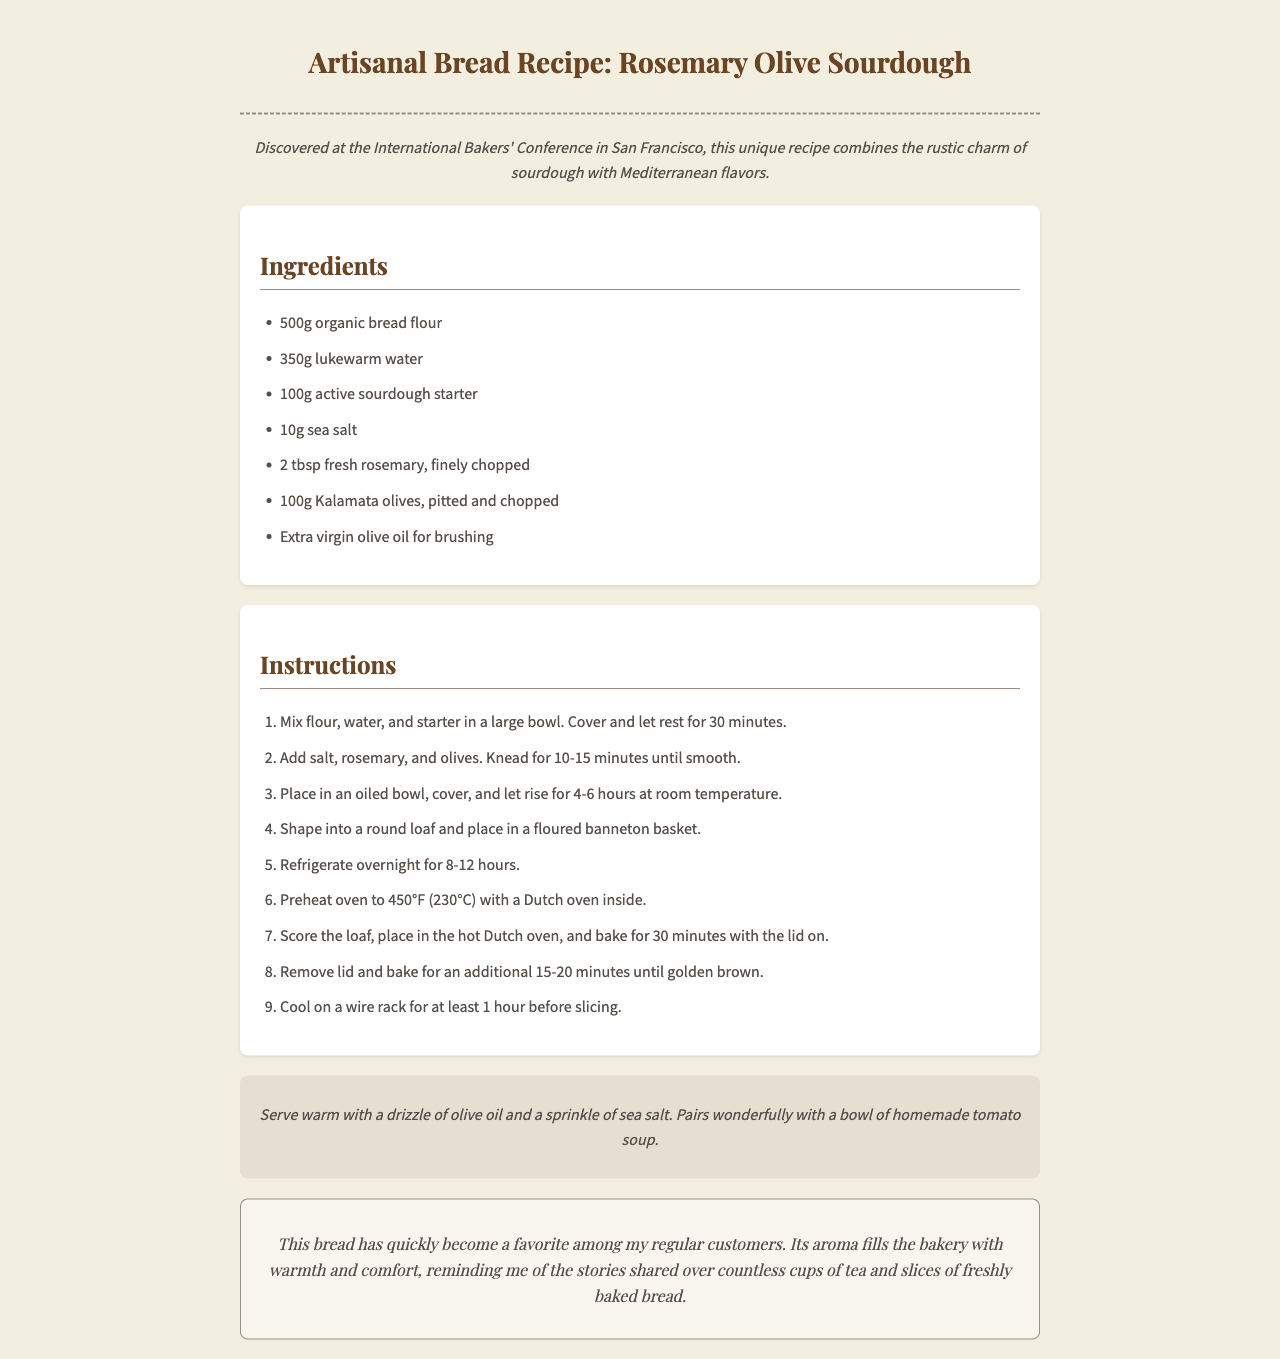What is the name of the bread? The name of the bread is presented in the title of the document.
Answer: Rosemary Olive Sourdough How much bread flour is needed? The amount of bread flour is found in the ingredients section.
Answer: 500g What is the baking temperature? The baking temperature is specified in the instructions section.
Answer: 450°F (230°C) How many hours should the dough rise? The rising time for the dough is noted in the instructions.
Answer: 4-6 hours What ingredient is suggested for brushing? The suggested ingredient for brushing is mentioned under the ingredients list.
Answer: Extra virgin olive oil What is the resting time before kneading? The resting time before kneading is stated in the instructions.
Answer: 30 minutes What type of olives are used? The type of olives is given in the ingredients and relates to a specific flavor.
Answer: Kalamata olives How long should the bread cool before slicing? The cooling time before slicing is indicated in the instructions.
Answer: 1 hour 